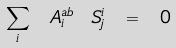<formula> <loc_0><loc_0><loc_500><loc_500>\sum _ { i } \ A _ { i } ^ { a b } \ S ^ { i } _ { j } \ = \ 0</formula> 